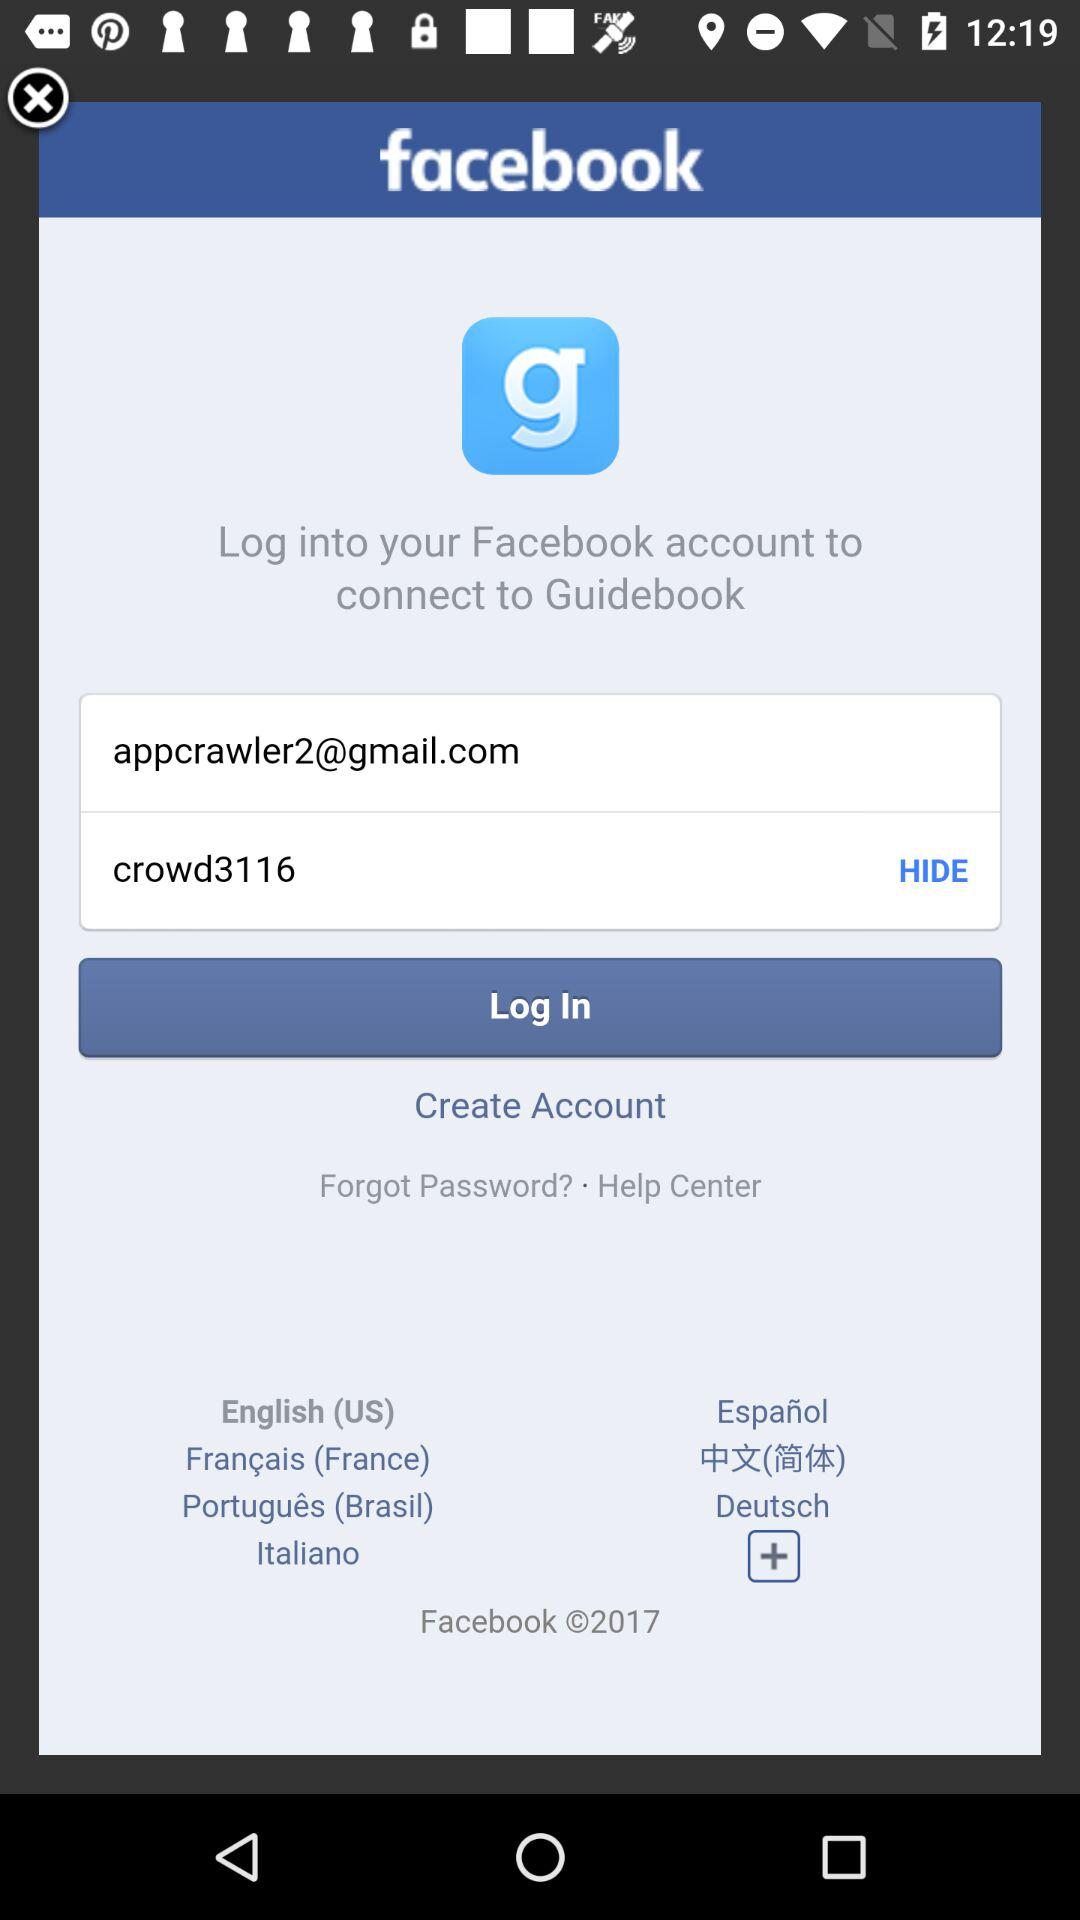What is the password? The password is "crowd3116". 